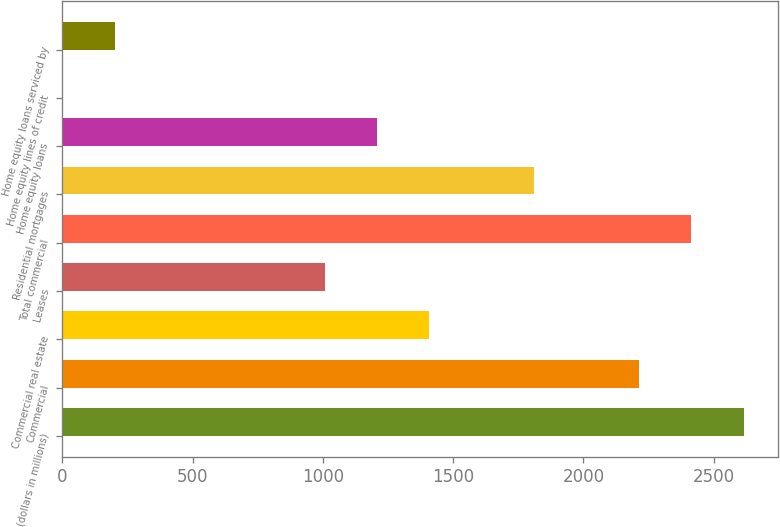Convert chart. <chart><loc_0><loc_0><loc_500><loc_500><bar_chart><fcel>(dollars in millions)<fcel>Commercial<fcel>Commercial real estate<fcel>Leases<fcel>Total commercial<fcel>Residential mortgages<fcel>Home equity loans<fcel>Home equity lines of credit<fcel>Home equity loans serviced by<nl><fcel>2615.3<fcel>2213.1<fcel>1408.7<fcel>1006.5<fcel>2414.2<fcel>1810.9<fcel>1207.6<fcel>1<fcel>202.1<nl></chart> 